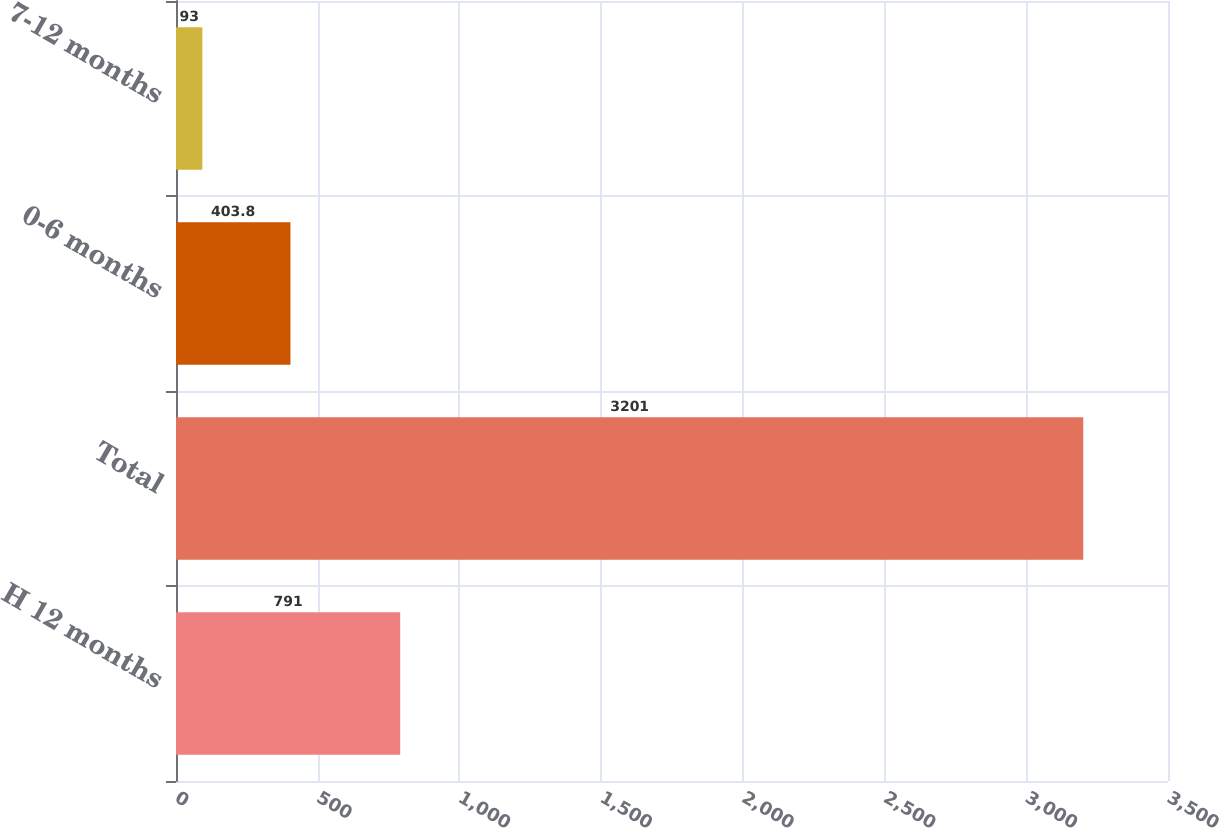Convert chart to OTSL. <chart><loc_0><loc_0><loc_500><loc_500><bar_chart><fcel>H 12 months<fcel>Total<fcel>0-6 months<fcel>7-12 months<nl><fcel>791<fcel>3201<fcel>403.8<fcel>93<nl></chart> 